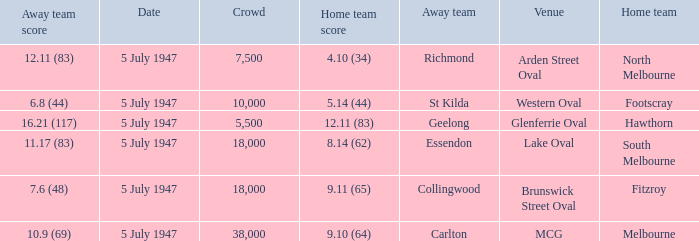What home team played an away team with a score of 6.8 (44)? Footscray. 